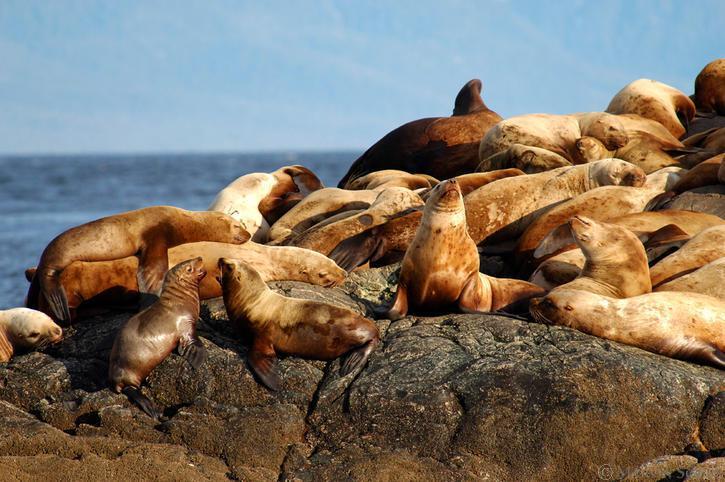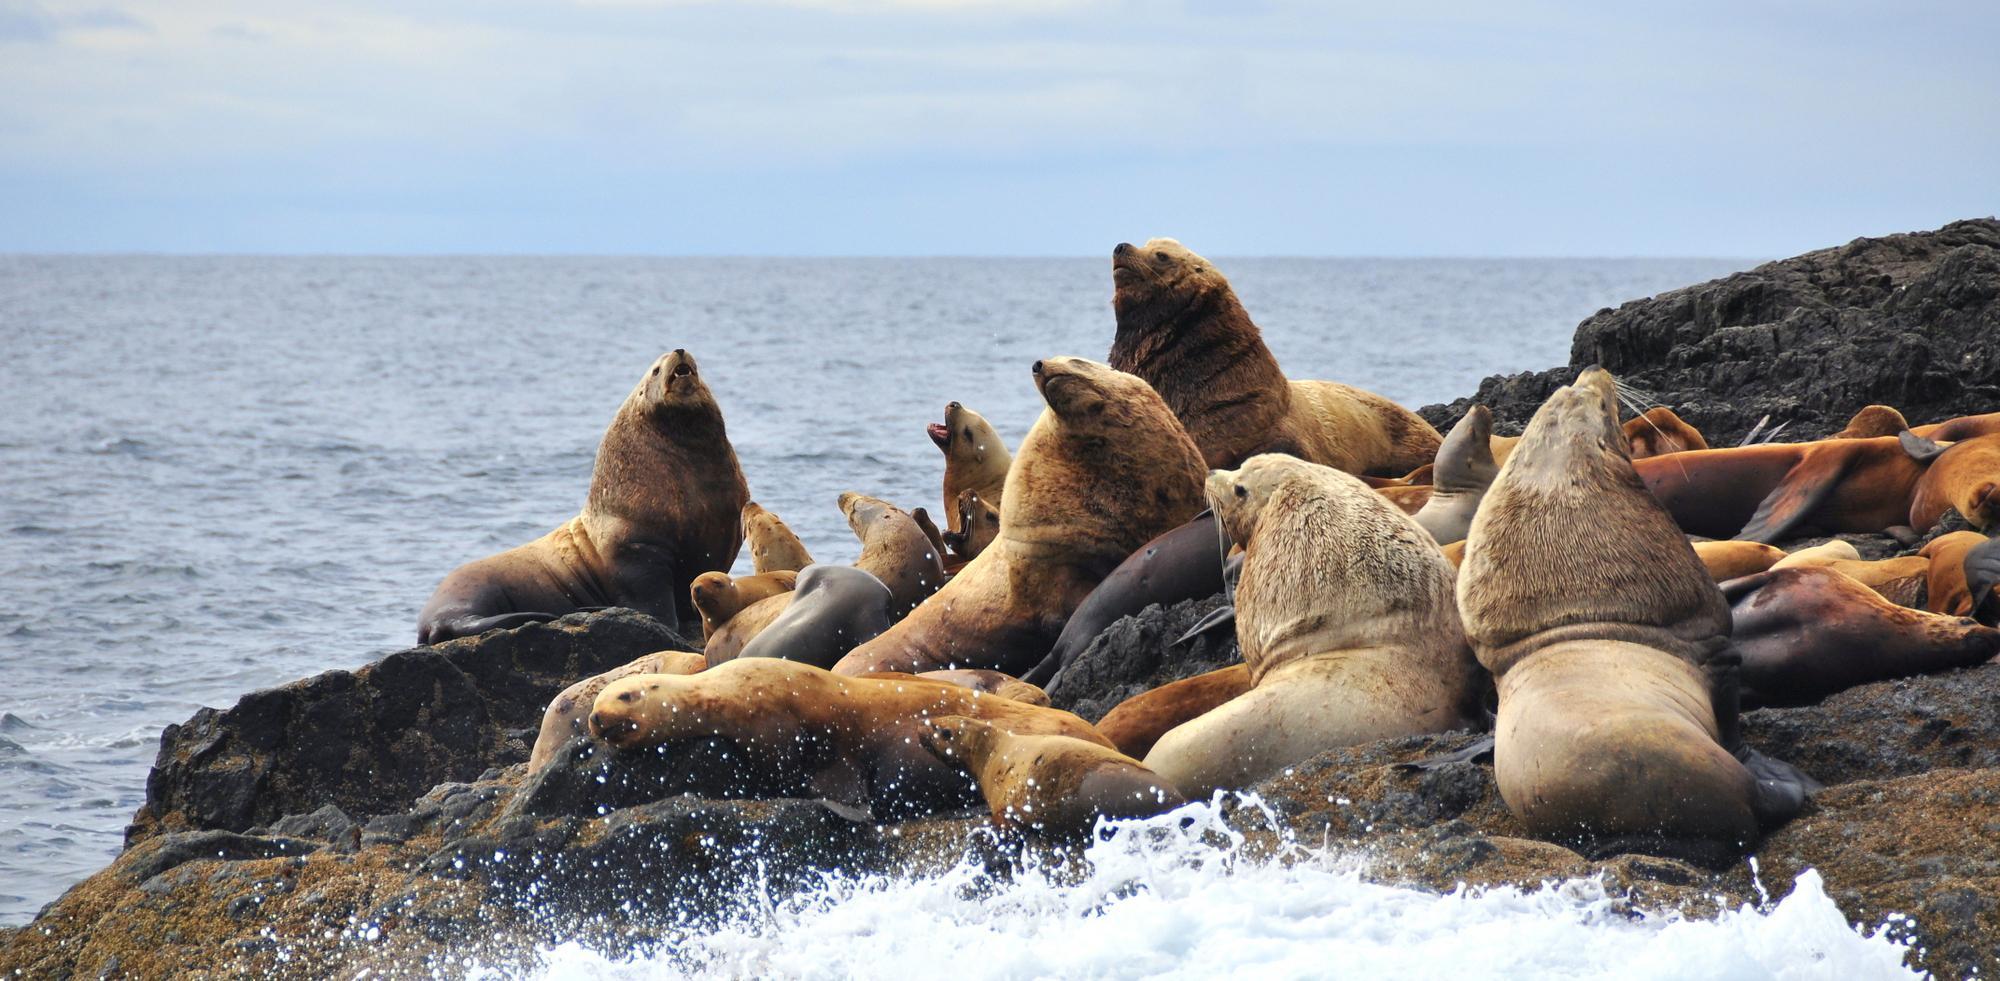The first image is the image on the left, the second image is the image on the right. Examine the images to the left and right. Is the description "There is no land on the horizon of the image on the left." accurate? Answer yes or no. Yes. 